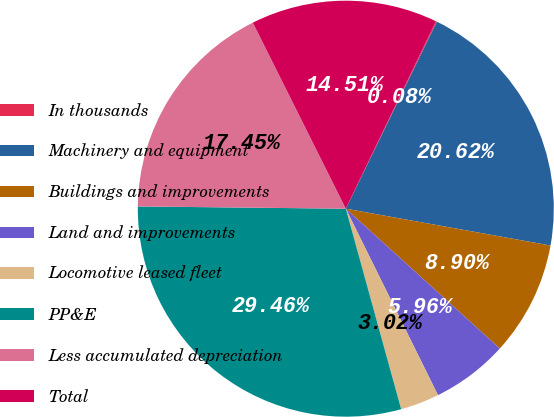Convert chart. <chart><loc_0><loc_0><loc_500><loc_500><pie_chart><fcel>In thousands<fcel>Machinery and equipment<fcel>Buildings and improvements<fcel>Land and improvements<fcel>Locomotive leased fleet<fcel>PP&E<fcel>Less accumulated depreciation<fcel>Total<nl><fcel>0.08%<fcel>20.62%<fcel>8.9%<fcel>5.96%<fcel>3.02%<fcel>29.46%<fcel>17.45%<fcel>14.51%<nl></chart> 